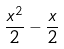Convert formula to latex. <formula><loc_0><loc_0><loc_500><loc_500>\frac { x ^ { 2 } } { 2 } - \frac { x } { 2 }</formula> 